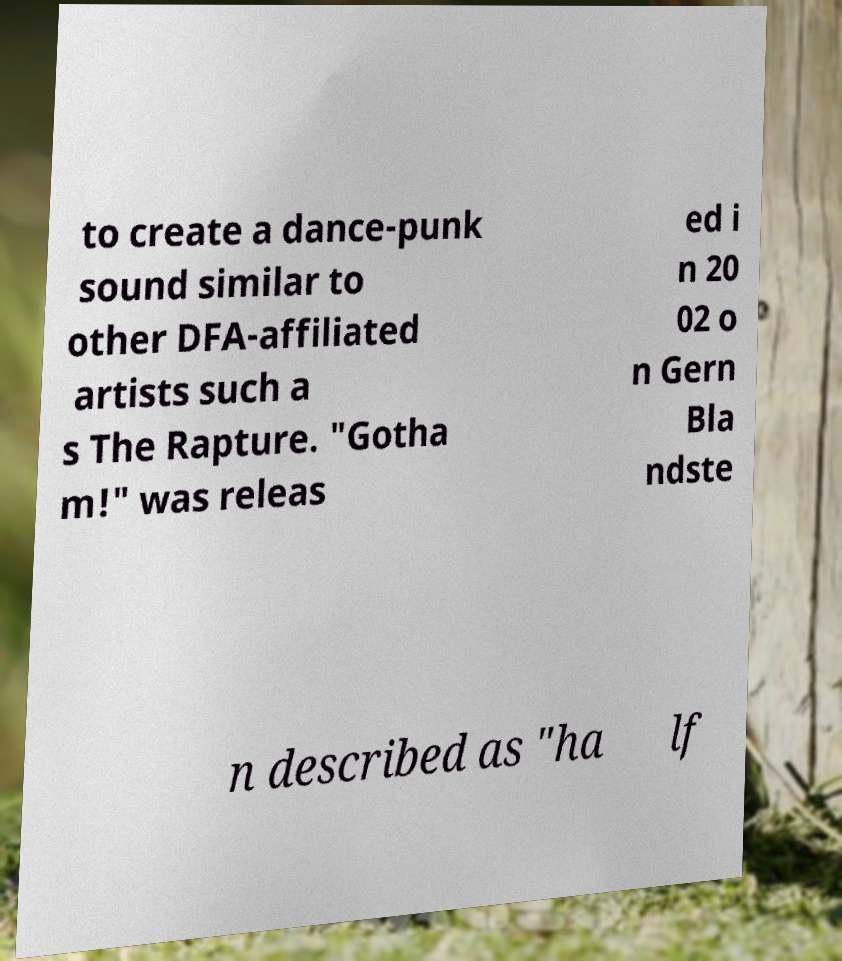Could you assist in decoding the text presented in this image and type it out clearly? to create a dance-punk sound similar to other DFA-affiliated artists such a s The Rapture. "Gotha m!" was releas ed i n 20 02 o n Gern Bla ndste n described as "ha lf 